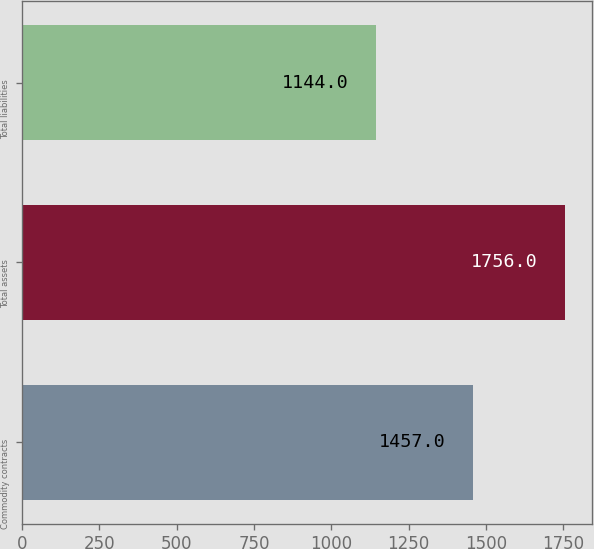Convert chart. <chart><loc_0><loc_0><loc_500><loc_500><bar_chart><fcel>Commodity contracts<fcel>Total assets<fcel>Total liabilities<nl><fcel>1457<fcel>1756<fcel>1144<nl></chart> 